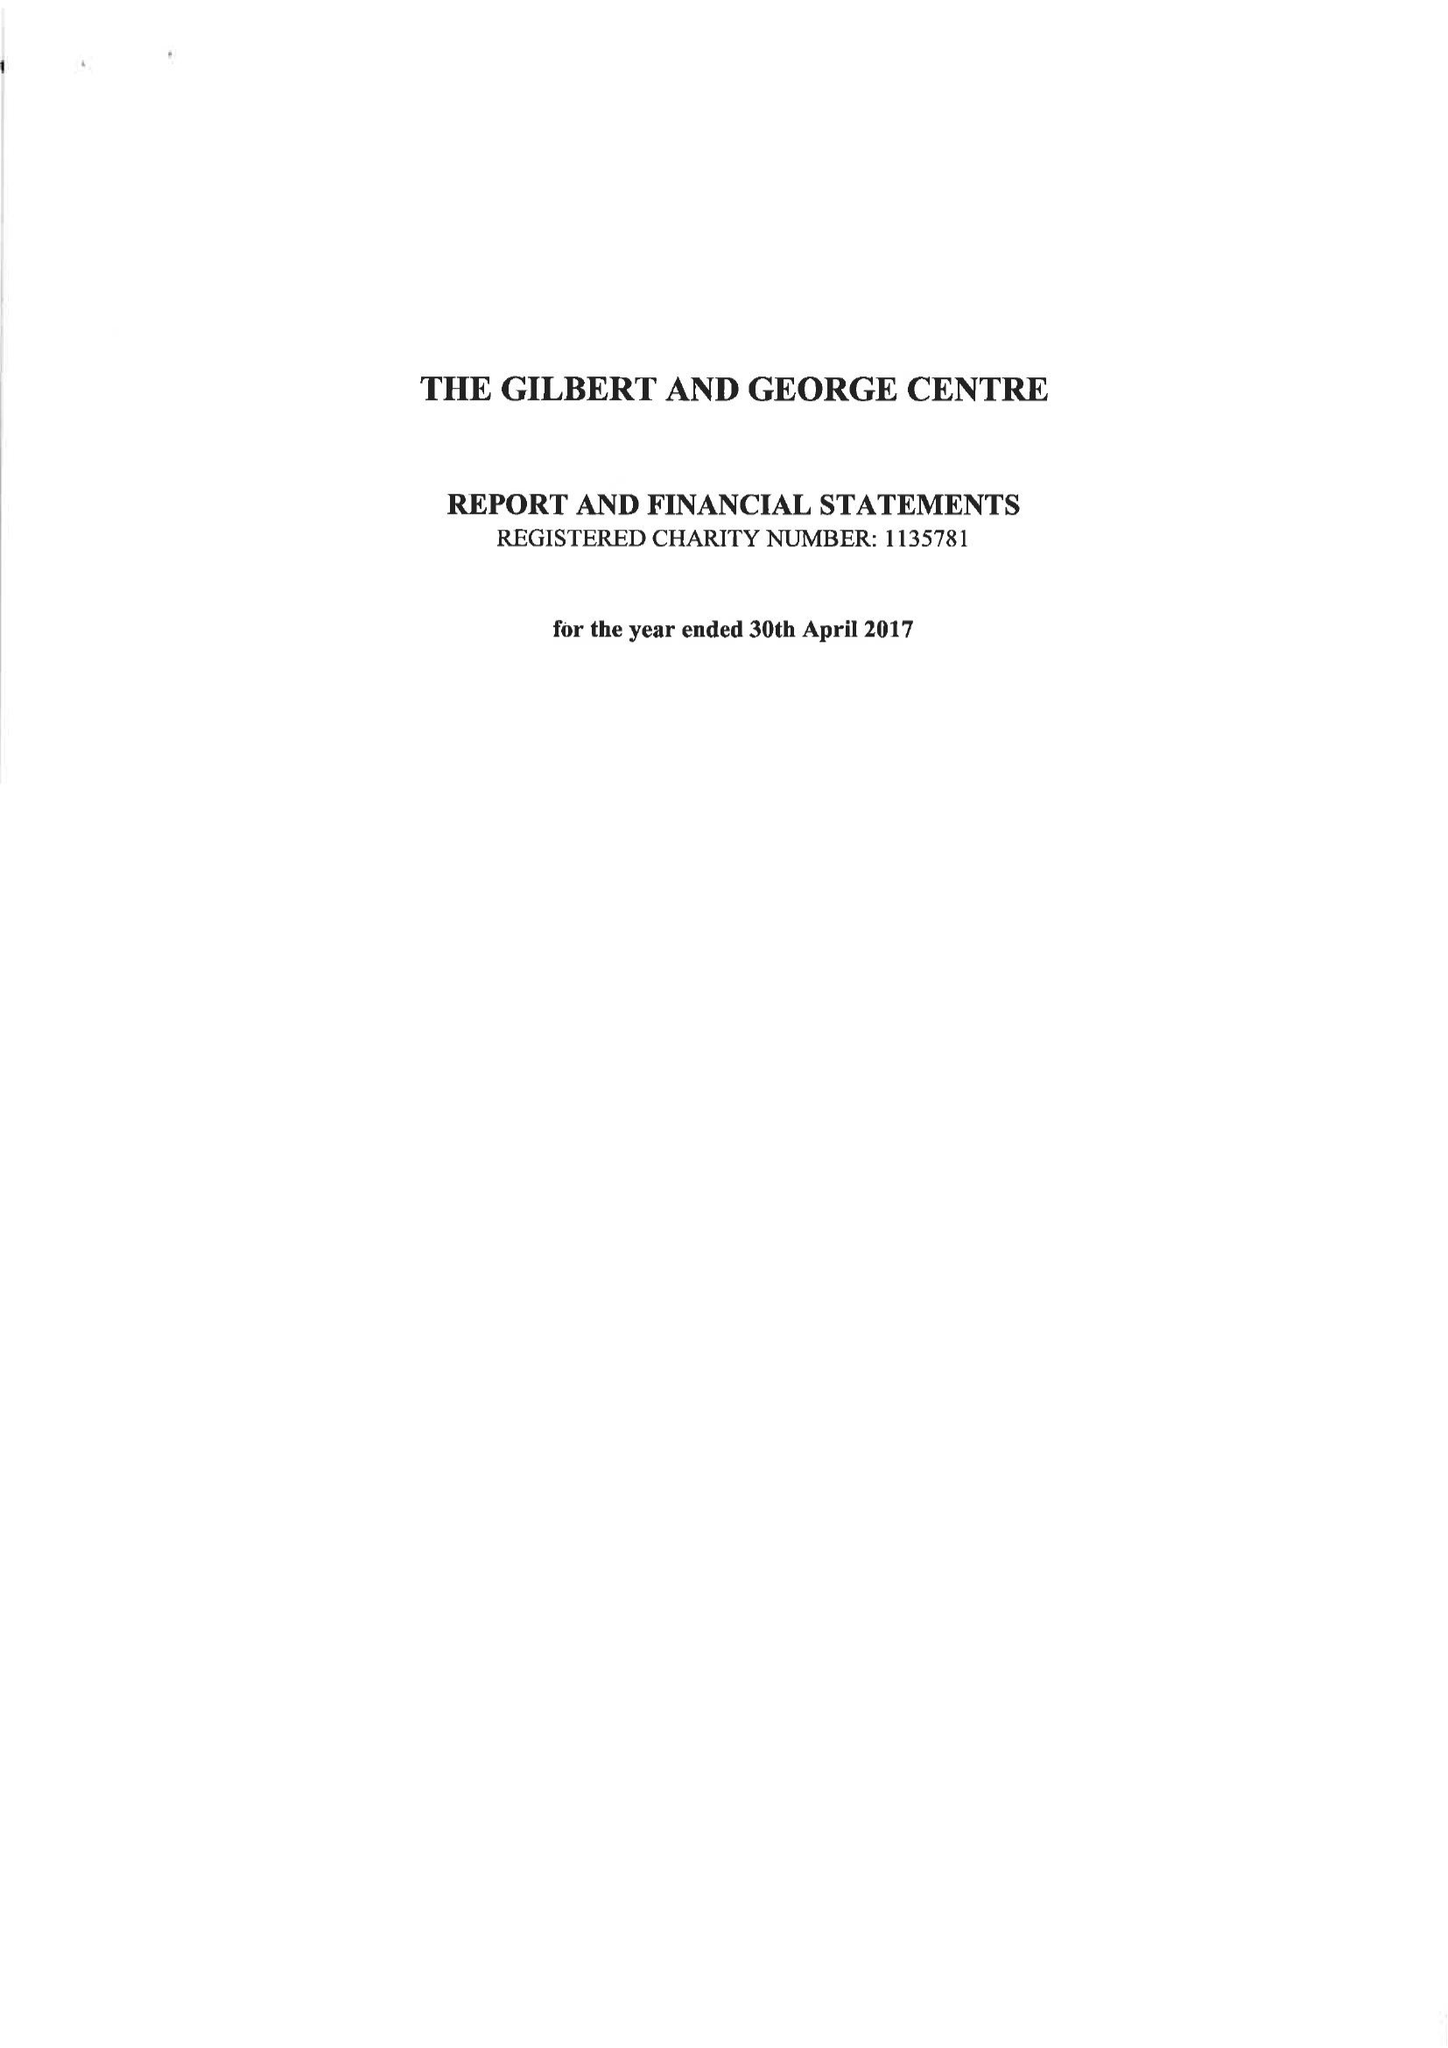What is the value for the charity_number?
Answer the question using a single word or phrase. 1135781 